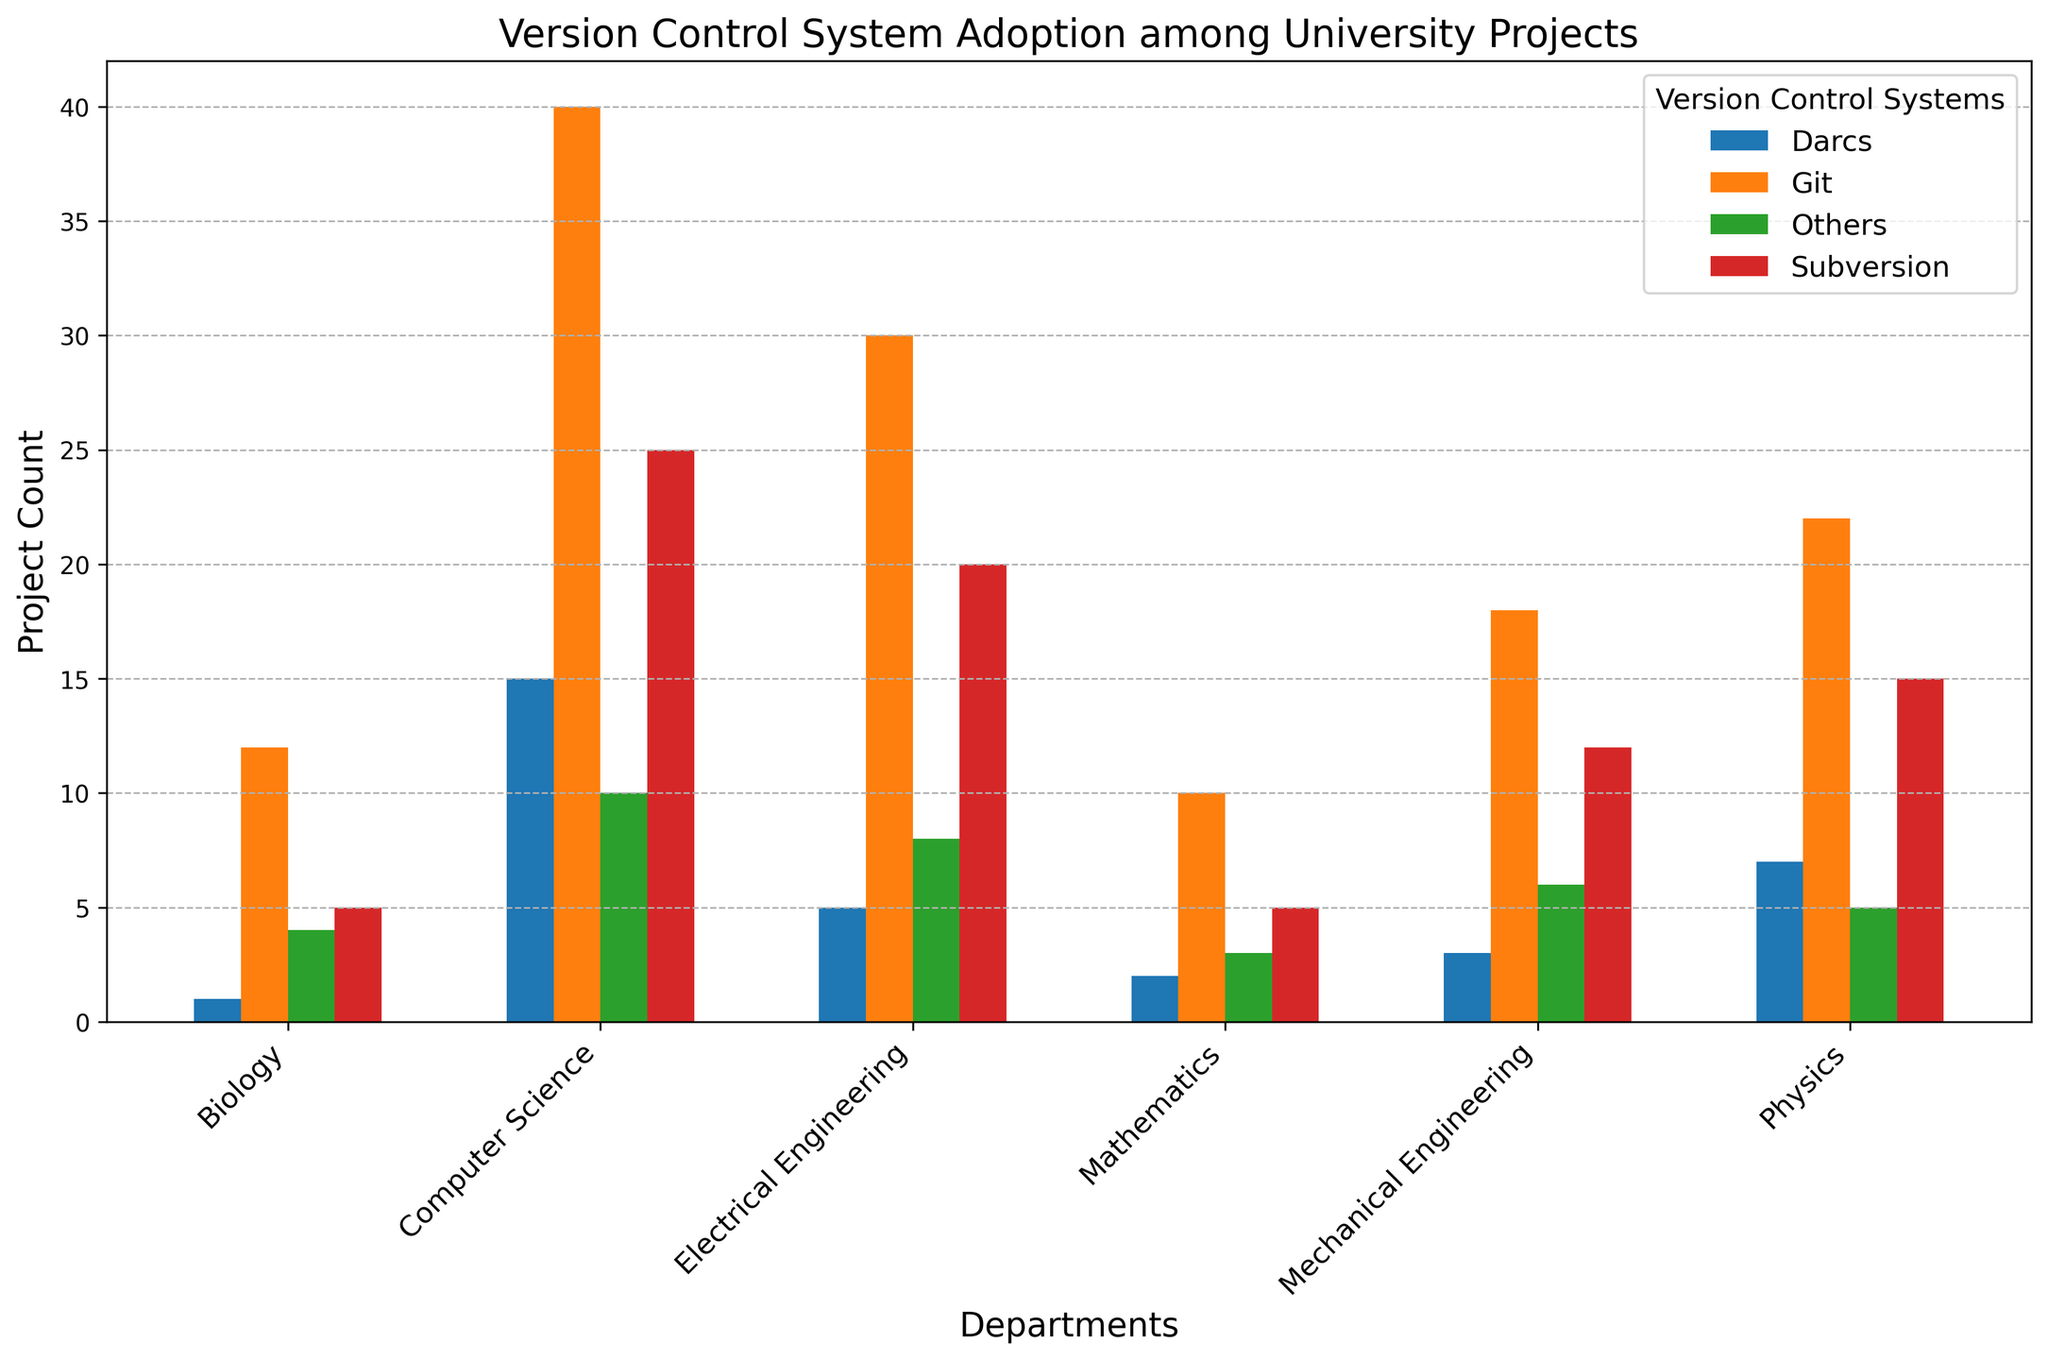Which department has the highest adoption of Git? The bar representing Git for each department should be compared visually. The tallest bar represents the highest adoption.
Answer: Computer Science Which version control system has the lowest overall adoption in Electrical Engineering? Look at the heights of the bars within Electrical Engineering and identify the shortest one.
Answer: Darcs What's the total number of projects using Subversion across all departments? Sum the heights of all Subversion bars across all departments. Subversion project counts: 25 (CS) + 20 (EE) + 12 (ME) + 5 (Bio) + 15 (Physics) + 5 (Math) = 82
Answer: 82 Which department has the greatest difference in project count between Git and Darcs? For each department, calculate the absolute difference between the heights of the Git and Darcs bars. The department with the largest difference is the answer. CS: 40-15=25, EE: 30-5=25, ME: 18-3=15, Bio: 12-1=11, Phys: 22-7=15, Math: 10-2=8.
Answer: Computer Science and Electrical Engineering How many more projects use Git than all other version control systems combined in Physics? Calculate the difference between the height of the Git bar and the sum of the heights of the other bars in Physics. Git: 22, Others combined: 15+7+5 = 27. Difference: 22 - 27 = -5
Answer: 5 fewer Which department has the most varied adoption across version control systems? Identify the department where the heights of the bars are most disparate by visually assessing the variability between the highest and lowest bar heights. This will likely be where no single version control system is predominantly adopted.
Answer: Computer Science What is the proportional use of Darcs in the Computer Science department compared to the entire university? First, sum the total number of Darcs projects across all departments: 15 (CS) + 5 (EE) + 3 (ME) + 1 (Bio) + 7 (Phys) + 2 (Math) = 33. Then calculate the proportion of the Computer Science Darcs projects: 15 / 33
Answer: 15/33 or approximately 0.45 Which department uses 'Others' version control systems the least? Compare the bar heights representing the 'Others' category across all departments. The department with the shortest bar height is the answer.
Answer: Mathematics What is the average number of projects per department using version control systems? Sum the total number of projects across all departments and divide by the number of departments. Total projects: (40+25+15+10) + (30+20+5+8) + (18+12+3+6) + (12+5+1+4) + (22+15+7+5) + (10+5+2+3) = 294 projects. There are 6 departments: 294/6 = 49
Answer: 49 